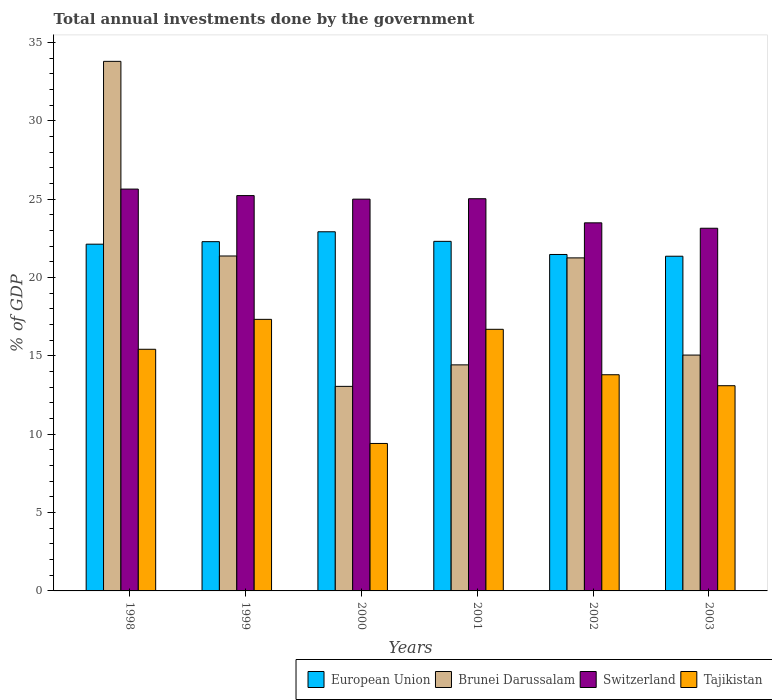How many different coloured bars are there?
Keep it short and to the point. 4. How many groups of bars are there?
Ensure brevity in your answer.  6. Are the number of bars per tick equal to the number of legend labels?
Provide a short and direct response. Yes. Are the number of bars on each tick of the X-axis equal?
Offer a very short reply. Yes. How many bars are there on the 1st tick from the left?
Give a very brief answer. 4. In how many cases, is the number of bars for a given year not equal to the number of legend labels?
Your answer should be compact. 0. What is the total annual investments done by the government in Switzerland in 2000?
Offer a very short reply. 25.01. Across all years, what is the maximum total annual investments done by the government in European Union?
Your response must be concise. 22.93. Across all years, what is the minimum total annual investments done by the government in European Union?
Keep it short and to the point. 21.37. In which year was the total annual investments done by the government in Brunei Darussalam minimum?
Your response must be concise. 2000. What is the total total annual investments done by the government in Brunei Darussalam in the graph?
Offer a very short reply. 118.99. What is the difference between the total annual investments done by the government in Switzerland in 2000 and that in 2003?
Make the answer very short. 1.86. What is the difference between the total annual investments done by the government in Switzerland in 1998 and the total annual investments done by the government in Brunei Darussalam in 1999?
Your response must be concise. 4.27. What is the average total annual investments done by the government in Tajikistan per year?
Offer a very short reply. 14.3. In the year 1999, what is the difference between the total annual investments done by the government in European Union and total annual investments done by the government in Brunei Darussalam?
Provide a short and direct response. 0.92. In how many years, is the total annual investments done by the government in Switzerland greater than 32 %?
Keep it short and to the point. 0. What is the ratio of the total annual investments done by the government in Brunei Darussalam in 1999 to that in 2000?
Your answer should be very brief. 1.64. Is the total annual investments done by the government in Brunei Darussalam in 2002 less than that in 2003?
Provide a succinct answer. No. Is the difference between the total annual investments done by the government in European Union in 1998 and 2003 greater than the difference between the total annual investments done by the government in Brunei Darussalam in 1998 and 2003?
Your response must be concise. No. What is the difference between the highest and the second highest total annual investments done by the government in Brunei Darussalam?
Give a very brief answer. 12.43. What is the difference between the highest and the lowest total annual investments done by the government in Tajikistan?
Provide a succinct answer. 7.92. Is the sum of the total annual investments done by the government in Brunei Darussalam in 1998 and 2000 greater than the maximum total annual investments done by the government in Tajikistan across all years?
Your answer should be compact. Yes. Is it the case that in every year, the sum of the total annual investments done by the government in Switzerland and total annual investments done by the government in Brunei Darussalam is greater than the sum of total annual investments done by the government in Tajikistan and total annual investments done by the government in European Union?
Offer a terse response. No. What does the 1st bar from the left in 1998 represents?
Give a very brief answer. European Union. What does the 3rd bar from the right in 2003 represents?
Your response must be concise. Brunei Darussalam. Is it the case that in every year, the sum of the total annual investments done by the government in Switzerland and total annual investments done by the government in Brunei Darussalam is greater than the total annual investments done by the government in Tajikistan?
Offer a very short reply. Yes. How many bars are there?
Your answer should be very brief. 24. Are all the bars in the graph horizontal?
Your answer should be compact. No. Are the values on the major ticks of Y-axis written in scientific E-notation?
Make the answer very short. No. Does the graph contain any zero values?
Keep it short and to the point. No. Where does the legend appear in the graph?
Offer a very short reply. Bottom right. How many legend labels are there?
Offer a very short reply. 4. What is the title of the graph?
Provide a short and direct response. Total annual investments done by the government. Does "Cameroon" appear as one of the legend labels in the graph?
Provide a succinct answer. No. What is the label or title of the Y-axis?
Ensure brevity in your answer.  % of GDP. What is the % of GDP in European Union in 1998?
Your answer should be very brief. 22.13. What is the % of GDP of Brunei Darussalam in 1998?
Your response must be concise. 33.81. What is the % of GDP in Switzerland in 1998?
Provide a succinct answer. 25.65. What is the % of GDP of Tajikistan in 1998?
Your answer should be compact. 15.43. What is the % of GDP in European Union in 1999?
Make the answer very short. 22.3. What is the % of GDP in Brunei Darussalam in 1999?
Provide a succinct answer. 21.38. What is the % of GDP of Switzerland in 1999?
Keep it short and to the point. 25.24. What is the % of GDP in Tajikistan in 1999?
Make the answer very short. 17.34. What is the % of GDP of European Union in 2000?
Keep it short and to the point. 22.93. What is the % of GDP of Brunei Darussalam in 2000?
Ensure brevity in your answer.  13.06. What is the % of GDP of Switzerland in 2000?
Your answer should be very brief. 25.01. What is the % of GDP in Tajikistan in 2000?
Ensure brevity in your answer.  9.41. What is the % of GDP in European Union in 2001?
Give a very brief answer. 22.31. What is the % of GDP of Brunei Darussalam in 2001?
Ensure brevity in your answer.  14.43. What is the % of GDP in Switzerland in 2001?
Keep it short and to the point. 25.04. What is the % of GDP in Tajikistan in 2001?
Offer a terse response. 16.7. What is the % of GDP of European Union in 2002?
Offer a terse response. 21.48. What is the % of GDP of Brunei Darussalam in 2002?
Offer a terse response. 21.26. What is the % of GDP of Switzerland in 2002?
Your answer should be very brief. 23.5. What is the % of GDP of Tajikistan in 2002?
Provide a succinct answer. 13.8. What is the % of GDP in European Union in 2003?
Your answer should be very brief. 21.37. What is the % of GDP in Brunei Darussalam in 2003?
Offer a very short reply. 15.06. What is the % of GDP in Switzerland in 2003?
Keep it short and to the point. 23.15. What is the % of GDP of Tajikistan in 2003?
Offer a very short reply. 13.1. Across all years, what is the maximum % of GDP of European Union?
Offer a very short reply. 22.93. Across all years, what is the maximum % of GDP of Brunei Darussalam?
Offer a very short reply. 33.81. Across all years, what is the maximum % of GDP of Switzerland?
Provide a succinct answer. 25.65. Across all years, what is the maximum % of GDP in Tajikistan?
Keep it short and to the point. 17.34. Across all years, what is the minimum % of GDP in European Union?
Your answer should be very brief. 21.37. Across all years, what is the minimum % of GDP of Brunei Darussalam?
Your answer should be very brief. 13.06. Across all years, what is the minimum % of GDP in Switzerland?
Your response must be concise. 23.15. Across all years, what is the minimum % of GDP in Tajikistan?
Your response must be concise. 9.41. What is the total % of GDP of European Union in the graph?
Ensure brevity in your answer.  132.51. What is the total % of GDP of Brunei Darussalam in the graph?
Provide a short and direct response. 118.99. What is the total % of GDP in Switzerland in the graph?
Keep it short and to the point. 147.58. What is the total % of GDP of Tajikistan in the graph?
Your answer should be compact. 85.77. What is the difference between the % of GDP of European Union in 1998 and that in 1999?
Ensure brevity in your answer.  -0.16. What is the difference between the % of GDP in Brunei Darussalam in 1998 and that in 1999?
Offer a very short reply. 12.43. What is the difference between the % of GDP of Switzerland in 1998 and that in 1999?
Your answer should be compact. 0.42. What is the difference between the % of GDP of Tajikistan in 1998 and that in 1999?
Offer a terse response. -1.91. What is the difference between the % of GDP in European Union in 1998 and that in 2000?
Provide a succinct answer. -0.79. What is the difference between the % of GDP in Brunei Darussalam in 1998 and that in 2000?
Provide a short and direct response. 20.75. What is the difference between the % of GDP in Switzerland in 1998 and that in 2000?
Provide a short and direct response. 0.64. What is the difference between the % of GDP of Tajikistan in 1998 and that in 2000?
Your answer should be compact. 6.01. What is the difference between the % of GDP in European Union in 1998 and that in 2001?
Your answer should be very brief. -0.18. What is the difference between the % of GDP of Brunei Darussalam in 1998 and that in 2001?
Your response must be concise. 19.38. What is the difference between the % of GDP of Switzerland in 1998 and that in 2001?
Your answer should be compact. 0.62. What is the difference between the % of GDP in Tajikistan in 1998 and that in 2001?
Your answer should be compact. -1.27. What is the difference between the % of GDP of European Union in 1998 and that in 2002?
Keep it short and to the point. 0.66. What is the difference between the % of GDP in Brunei Darussalam in 1998 and that in 2002?
Your answer should be very brief. 12.55. What is the difference between the % of GDP in Switzerland in 1998 and that in 2002?
Offer a very short reply. 2.15. What is the difference between the % of GDP in Tajikistan in 1998 and that in 2002?
Offer a very short reply. 1.63. What is the difference between the % of GDP of European Union in 1998 and that in 2003?
Keep it short and to the point. 0.77. What is the difference between the % of GDP of Brunei Darussalam in 1998 and that in 2003?
Provide a short and direct response. 18.75. What is the difference between the % of GDP of Switzerland in 1998 and that in 2003?
Provide a short and direct response. 2.5. What is the difference between the % of GDP of Tajikistan in 1998 and that in 2003?
Offer a terse response. 2.33. What is the difference between the % of GDP of European Union in 1999 and that in 2000?
Give a very brief answer. -0.63. What is the difference between the % of GDP in Brunei Darussalam in 1999 and that in 2000?
Ensure brevity in your answer.  8.32. What is the difference between the % of GDP of Switzerland in 1999 and that in 2000?
Provide a succinct answer. 0.23. What is the difference between the % of GDP of Tajikistan in 1999 and that in 2000?
Provide a short and direct response. 7.92. What is the difference between the % of GDP of European Union in 1999 and that in 2001?
Offer a terse response. -0.02. What is the difference between the % of GDP in Brunei Darussalam in 1999 and that in 2001?
Offer a terse response. 6.95. What is the difference between the % of GDP of Switzerland in 1999 and that in 2001?
Keep it short and to the point. 0.2. What is the difference between the % of GDP in Tajikistan in 1999 and that in 2001?
Provide a succinct answer. 0.64. What is the difference between the % of GDP of European Union in 1999 and that in 2002?
Ensure brevity in your answer.  0.82. What is the difference between the % of GDP of Brunei Darussalam in 1999 and that in 2002?
Your answer should be very brief. 0.12. What is the difference between the % of GDP of Switzerland in 1999 and that in 2002?
Provide a succinct answer. 1.74. What is the difference between the % of GDP of Tajikistan in 1999 and that in 2002?
Your answer should be compact. 3.54. What is the difference between the % of GDP of European Union in 1999 and that in 2003?
Offer a terse response. 0.93. What is the difference between the % of GDP of Brunei Darussalam in 1999 and that in 2003?
Your response must be concise. 6.32. What is the difference between the % of GDP of Switzerland in 1999 and that in 2003?
Provide a short and direct response. 2.08. What is the difference between the % of GDP in Tajikistan in 1999 and that in 2003?
Offer a very short reply. 4.24. What is the difference between the % of GDP in European Union in 2000 and that in 2001?
Offer a terse response. 0.61. What is the difference between the % of GDP of Brunei Darussalam in 2000 and that in 2001?
Offer a terse response. -1.37. What is the difference between the % of GDP in Switzerland in 2000 and that in 2001?
Offer a terse response. -0.03. What is the difference between the % of GDP in Tajikistan in 2000 and that in 2001?
Make the answer very short. -7.29. What is the difference between the % of GDP of European Union in 2000 and that in 2002?
Your answer should be very brief. 1.45. What is the difference between the % of GDP in Brunei Darussalam in 2000 and that in 2002?
Provide a succinct answer. -8.2. What is the difference between the % of GDP in Switzerland in 2000 and that in 2002?
Offer a very short reply. 1.51. What is the difference between the % of GDP of Tajikistan in 2000 and that in 2002?
Provide a short and direct response. -4.39. What is the difference between the % of GDP in European Union in 2000 and that in 2003?
Make the answer very short. 1.56. What is the difference between the % of GDP in Brunei Darussalam in 2000 and that in 2003?
Offer a terse response. -2. What is the difference between the % of GDP in Switzerland in 2000 and that in 2003?
Your answer should be compact. 1.86. What is the difference between the % of GDP of Tajikistan in 2000 and that in 2003?
Offer a terse response. -3.69. What is the difference between the % of GDP of European Union in 2001 and that in 2002?
Provide a short and direct response. 0.84. What is the difference between the % of GDP of Brunei Darussalam in 2001 and that in 2002?
Give a very brief answer. -6.83. What is the difference between the % of GDP of Switzerland in 2001 and that in 2002?
Offer a very short reply. 1.54. What is the difference between the % of GDP of European Union in 2001 and that in 2003?
Give a very brief answer. 0.95. What is the difference between the % of GDP in Brunei Darussalam in 2001 and that in 2003?
Provide a succinct answer. -0.63. What is the difference between the % of GDP in Switzerland in 2001 and that in 2003?
Offer a terse response. 1.88. What is the difference between the % of GDP in European Union in 2002 and that in 2003?
Keep it short and to the point. 0.11. What is the difference between the % of GDP of Brunei Darussalam in 2002 and that in 2003?
Give a very brief answer. 6.2. What is the difference between the % of GDP in Switzerland in 2002 and that in 2003?
Make the answer very short. 0.34. What is the difference between the % of GDP in Tajikistan in 2002 and that in 2003?
Make the answer very short. 0.7. What is the difference between the % of GDP of European Union in 1998 and the % of GDP of Brunei Darussalam in 1999?
Provide a short and direct response. 0.75. What is the difference between the % of GDP in European Union in 1998 and the % of GDP in Switzerland in 1999?
Your answer should be compact. -3.1. What is the difference between the % of GDP of European Union in 1998 and the % of GDP of Tajikistan in 1999?
Your answer should be very brief. 4.8. What is the difference between the % of GDP of Brunei Darussalam in 1998 and the % of GDP of Switzerland in 1999?
Your answer should be very brief. 8.57. What is the difference between the % of GDP of Brunei Darussalam in 1998 and the % of GDP of Tajikistan in 1999?
Keep it short and to the point. 16.47. What is the difference between the % of GDP of Switzerland in 1998 and the % of GDP of Tajikistan in 1999?
Ensure brevity in your answer.  8.32. What is the difference between the % of GDP of European Union in 1998 and the % of GDP of Brunei Darussalam in 2000?
Keep it short and to the point. 9.08. What is the difference between the % of GDP of European Union in 1998 and the % of GDP of Switzerland in 2000?
Provide a succinct answer. -2.87. What is the difference between the % of GDP in European Union in 1998 and the % of GDP in Tajikistan in 2000?
Keep it short and to the point. 12.72. What is the difference between the % of GDP in Brunei Darussalam in 1998 and the % of GDP in Switzerland in 2000?
Your answer should be compact. 8.8. What is the difference between the % of GDP in Brunei Darussalam in 1998 and the % of GDP in Tajikistan in 2000?
Offer a terse response. 24.39. What is the difference between the % of GDP in Switzerland in 1998 and the % of GDP in Tajikistan in 2000?
Make the answer very short. 16.24. What is the difference between the % of GDP of European Union in 1998 and the % of GDP of Brunei Darussalam in 2001?
Your answer should be compact. 7.7. What is the difference between the % of GDP of European Union in 1998 and the % of GDP of Switzerland in 2001?
Provide a succinct answer. -2.9. What is the difference between the % of GDP of European Union in 1998 and the % of GDP of Tajikistan in 2001?
Your answer should be very brief. 5.43. What is the difference between the % of GDP in Brunei Darussalam in 1998 and the % of GDP in Switzerland in 2001?
Provide a succinct answer. 8.77. What is the difference between the % of GDP in Brunei Darussalam in 1998 and the % of GDP in Tajikistan in 2001?
Make the answer very short. 17.11. What is the difference between the % of GDP of Switzerland in 1998 and the % of GDP of Tajikistan in 2001?
Your answer should be very brief. 8.95. What is the difference between the % of GDP in European Union in 1998 and the % of GDP in Brunei Darussalam in 2002?
Make the answer very short. 0.87. What is the difference between the % of GDP of European Union in 1998 and the % of GDP of Switzerland in 2002?
Offer a very short reply. -1.36. What is the difference between the % of GDP of European Union in 1998 and the % of GDP of Tajikistan in 2002?
Your answer should be compact. 8.33. What is the difference between the % of GDP of Brunei Darussalam in 1998 and the % of GDP of Switzerland in 2002?
Offer a terse response. 10.31. What is the difference between the % of GDP in Brunei Darussalam in 1998 and the % of GDP in Tajikistan in 2002?
Provide a short and direct response. 20.01. What is the difference between the % of GDP of Switzerland in 1998 and the % of GDP of Tajikistan in 2002?
Offer a terse response. 11.85. What is the difference between the % of GDP of European Union in 1998 and the % of GDP of Brunei Darussalam in 2003?
Ensure brevity in your answer.  7.08. What is the difference between the % of GDP in European Union in 1998 and the % of GDP in Switzerland in 2003?
Give a very brief answer. -1.02. What is the difference between the % of GDP of European Union in 1998 and the % of GDP of Tajikistan in 2003?
Make the answer very short. 9.03. What is the difference between the % of GDP in Brunei Darussalam in 1998 and the % of GDP in Switzerland in 2003?
Your response must be concise. 10.65. What is the difference between the % of GDP in Brunei Darussalam in 1998 and the % of GDP in Tajikistan in 2003?
Make the answer very short. 20.71. What is the difference between the % of GDP of Switzerland in 1998 and the % of GDP of Tajikistan in 2003?
Ensure brevity in your answer.  12.55. What is the difference between the % of GDP in European Union in 1999 and the % of GDP in Brunei Darussalam in 2000?
Make the answer very short. 9.24. What is the difference between the % of GDP in European Union in 1999 and the % of GDP in Switzerland in 2000?
Offer a very short reply. -2.71. What is the difference between the % of GDP in European Union in 1999 and the % of GDP in Tajikistan in 2000?
Your answer should be very brief. 12.88. What is the difference between the % of GDP of Brunei Darussalam in 1999 and the % of GDP of Switzerland in 2000?
Provide a short and direct response. -3.63. What is the difference between the % of GDP of Brunei Darussalam in 1999 and the % of GDP of Tajikistan in 2000?
Your answer should be compact. 11.97. What is the difference between the % of GDP of Switzerland in 1999 and the % of GDP of Tajikistan in 2000?
Ensure brevity in your answer.  15.82. What is the difference between the % of GDP of European Union in 1999 and the % of GDP of Brunei Darussalam in 2001?
Your answer should be very brief. 7.87. What is the difference between the % of GDP of European Union in 1999 and the % of GDP of Switzerland in 2001?
Offer a very short reply. -2.74. What is the difference between the % of GDP of European Union in 1999 and the % of GDP of Tajikistan in 2001?
Your answer should be very brief. 5.6. What is the difference between the % of GDP in Brunei Darussalam in 1999 and the % of GDP in Switzerland in 2001?
Your answer should be very brief. -3.66. What is the difference between the % of GDP in Brunei Darussalam in 1999 and the % of GDP in Tajikistan in 2001?
Ensure brevity in your answer.  4.68. What is the difference between the % of GDP in Switzerland in 1999 and the % of GDP in Tajikistan in 2001?
Ensure brevity in your answer.  8.54. What is the difference between the % of GDP in European Union in 1999 and the % of GDP in Brunei Darussalam in 2002?
Ensure brevity in your answer.  1.04. What is the difference between the % of GDP in European Union in 1999 and the % of GDP in Switzerland in 2002?
Offer a terse response. -1.2. What is the difference between the % of GDP of European Union in 1999 and the % of GDP of Tajikistan in 2002?
Offer a very short reply. 8.5. What is the difference between the % of GDP of Brunei Darussalam in 1999 and the % of GDP of Switzerland in 2002?
Your answer should be very brief. -2.12. What is the difference between the % of GDP of Brunei Darussalam in 1999 and the % of GDP of Tajikistan in 2002?
Offer a terse response. 7.58. What is the difference between the % of GDP in Switzerland in 1999 and the % of GDP in Tajikistan in 2002?
Your answer should be very brief. 11.44. What is the difference between the % of GDP of European Union in 1999 and the % of GDP of Brunei Darussalam in 2003?
Ensure brevity in your answer.  7.24. What is the difference between the % of GDP in European Union in 1999 and the % of GDP in Switzerland in 2003?
Provide a succinct answer. -0.86. What is the difference between the % of GDP in European Union in 1999 and the % of GDP in Tajikistan in 2003?
Offer a terse response. 9.2. What is the difference between the % of GDP in Brunei Darussalam in 1999 and the % of GDP in Switzerland in 2003?
Provide a short and direct response. -1.77. What is the difference between the % of GDP of Brunei Darussalam in 1999 and the % of GDP of Tajikistan in 2003?
Your response must be concise. 8.28. What is the difference between the % of GDP in Switzerland in 1999 and the % of GDP in Tajikistan in 2003?
Make the answer very short. 12.14. What is the difference between the % of GDP of European Union in 2000 and the % of GDP of Brunei Darussalam in 2001?
Your answer should be compact. 8.5. What is the difference between the % of GDP in European Union in 2000 and the % of GDP in Switzerland in 2001?
Offer a very short reply. -2.11. What is the difference between the % of GDP of European Union in 2000 and the % of GDP of Tajikistan in 2001?
Provide a short and direct response. 6.23. What is the difference between the % of GDP of Brunei Darussalam in 2000 and the % of GDP of Switzerland in 2001?
Offer a very short reply. -11.98. What is the difference between the % of GDP of Brunei Darussalam in 2000 and the % of GDP of Tajikistan in 2001?
Offer a terse response. -3.64. What is the difference between the % of GDP of Switzerland in 2000 and the % of GDP of Tajikistan in 2001?
Make the answer very short. 8.31. What is the difference between the % of GDP in European Union in 2000 and the % of GDP in Brunei Darussalam in 2002?
Provide a succinct answer. 1.67. What is the difference between the % of GDP in European Union in 2000 and the % of GDP in Switzerland in 2002?
Provide a short and direct response. -0.57. What is the difference between the % of GDP in European Union in 2000 and the % of GDP in Tajikistan in 2002?
Provide a succinct answer. 9.13. What is the difference between the % of GDP in Brunei Darussalam in 2000 and the % of GDP in Switzerland in 2002?
Make the answer very short. -10.44. What is the difference between the % of GDP in Brunei Darussalam in 2000 and the % of GDP in Tajikistan in 2002?
Your answer should be compact. -0.74. What is the difference between the % of GDP of Switzerland in 2000 and the % of GDP of Tajikistan in 2002?
Your response must be concise. 11.21. What is the difference between the % of GDP of European Union in 2000 and the % of GDP of Brunei Darussalam in 2003?
Keep it short and to the point. 7.87. What is the difference between the % of GDP of European Union in 2000 and the % of GDP of Switzerland in 2003?
Ensure brevity in your answer.  -0.23. What is the difference between the % of GDP of European Union in 2000 and the % of GDP of Tajikistan in 2003?
Provide a succinct answer. 9.83. What is the difference between the % of GDP in Brunei Darussalam in 2000 and the % of GDP in Switzerland in 2003?
Provide a short and direct response. -10.09. What is the difference between the % of GDP in Brunei Darussalam in 2000 and the % of GDP in Tajikistan in 2003?
Your response must be concise. -0.04. What is the difference between the % of GDP of Switzerland in 2000 and the % of GDP of Tajikistan in 2003?
Make the answer very short. 11.91. What is the difference between the % of GDP of European Union in 2001 and the % of GDP of Brunei Darussalam in 2002?
Ensure brevity in your answer.  1.06. What is the difference between the % of GDP in European Union in 2001 and the % of GDP in Switzerland in 2002?
Offer a very short reply. -1.18. What is the difference between the % of GDP in European Union in 2001 and the % of GDP in Tajikistan in 2002?
Offer a very short reply. 8.51. What is the difference between the % of GDP of Brunei Darussalam in 2001 and the % of GDP of Switzerland in 2002?
Provide a short and direct response. -9.07. What is the difference between the % of GDP in Brunei Darussalam in 2001 and the % of GDP in Tajikistan in 2002?
Make the answer very short. 0.63. What is the difference between the % of GDP in Switzerland in 2001 and the % of GDP in Tajikistan in 2002?
Offer a very short reply. 11.24. What is the difference between the % of GDP in European Union in 2001 and the % of GDP in Brunei Darussalam in 2003?
Offer a terse response. 7.26. What is the difference between the % of GDP in European Union in 2001 and the % of GDP in Switzerland in 2003?
Offer a terse response. -0.84. What is the difference between the % of GDP of European Union in 2001 and the % of GDP of Tajikistan in 2003?
Give a very brief answer. 9.21. What is the difference between the % of GDP of Brunei Darussalam in 2001 and the % of GDP of Switzerland in 2003?
Make the answer very short. -8.72. What is the difference between the % of GDP of Brunei Darussalam in 2001 and the % of GDP of Tajikistan in 2003?
Your answer should be very brief. 1.33. What is the difference between the % of GDP in Switzerland in 2001 and the % of GDP in Tajikistan in 2003?
Offer a terse response. 11.94. What is the difference between the % of GDP of European Union in 2002 and the % of GDP of Brunei Darussalam in 2003?
Keep it short and to the point. 6.42. What is the difference between the % of GDP of European Union in 2002 and the % of GDP of Switzerland in 2003?
Provide a succinct answer. -1.67. What is the difference between the % of GDP in European Union in 2002 and the % of GDP in Tajikistan in 2003?
Make the answer very short. 8.38. What is the difference between the % of GDP in Brunei Darussalam in 2002 and the % of GDP in Switzerland in 2003?
Offer a terse response. -1.89. What is the difference between the % of GDP in Brunei Darussalam in 2002 and the % of GDP in Tajikistan in 2003?
Provide a succinct answer. 8.16. What is the difference between the % of GDP of Switzerland in 2002 and the % of GDP of Tajikistan in 2003?
Offer a very short reply. 10.4. What is the average % of GDP of European Union per year?
Provide a succinct answer. 22.09. What is the average % of GDP of Brunei Darussalam per year?
Your response must be concise. 19.83. What is the average % of GDP of Switzerland per year?
Your answer should be very brief. 24.6. What is the average % of GDP in Tajikistan per year?
Ensure brevity in your answer.  14.3. In the year 1998, what is the difference between the % of GDP of European Union and % of GDP of Brunei Darussalam?
Provide a succinct answer. -11.67. In the year 1998, what is the difference between the % of GDP of European Union and % of GDP of Switzerland?
Give a very brief answer. -3.52. In the year 1998, what is the difference between the % of GDP of European Union and % of GDP of Tajikistan?
Your answer should be very brief. 6.71. In the year 1998, what is the difference between the % of GDP in Brunei Darussalam and % of GDP in Switzerland?
Ensure brevity in your answer.  8.15. In the year 1998, what is the difference between the % of GDP of Brunei Darussalam and % of GDP of Tajikistan?
Make the answer very short. 18.38. In the year 1998, what is the difference between the % of GDP of Switzerland and % of GDP of Tajikistan?
Your answer should be compact. 10.23. In the year 1999, what is the difference between the % of GDP of European Union and % of GDP of Brunei Darussalam?
Make the answer very short. 0.92. In the year 1999, what is the difference between the % of GDP of European Union and % of GDP of Switzerland?
Your answer should be very brief. -2.94. In the year 1999, what is the difference between the % of GDP in European Union and % of GDP in Tajikistan?
Your answer should be very brief. 4.96. In the year 1999, what is the difference between the % of GDP in Brunei Darussalam and % of GDP in Switzerland?
Give a very brief answer. -3.86. In the year 1999, what is the difference between the % of GDP in Brunei Darussalam and % of GDP in Tajikistan?
Ensure brevity in your answer.  4.04. In the year 1999, what is the difference between the % of GDP of Switzerland and % of GDP of Tajikistan?
Make the answer very short. 7.9. In the year 2000, what is the difference between the % of GDP in European Union and % of GDP in Brunei Darussalam?
Offer a very short reply. 9.87. In the year 2000, what is the difference between the % of GDP in European Union and % of GDP in Switzerland?
Offer a terse response. -2.08. In the year 2000, what is the difference between the % of GDP of European Union and % of GDP of Tajikistan?
Provide a short and direct response. 13.51. In the year 2000, what is the difference between the % of GDP in Brunei Darussalam and % of GDP in Switzerland?
Make the answer very short. -11.95. In the year 2000, what is the difference between the % of GDP of Brunei Darussalam and % of GDP of Tajikistan?
Your answer should be very brief. 3.64. In the year 2000, what is the difference between the % of GDP in Switzerland and % of GDP in Tajikistan?
Provide a short and direct response. 15.6. In the year 2001, what is the difference between the % of GDP in European Union and % of GDP in Brunei Darussalam?
Your answer should be compact. 7.88. In the year 2001, what is the difference between the % of GDP in European Union and % of GDP in Switzerland?
Provide a succinct answer. -2.72. In the year 2001, what is the difference between the % of GDP in European Union and % of GDP in Tajikistan?
Keep it short and to the point. 5.61. In the year 2001, what is the difference between the % of GDP in Brunei Darussalam and % of GDP in Switzerland?
Offer a very short reply. -10.61. In the year 2001, what is the difference between the % of GDP in Brunei Darussalam and % of GDP in Tajikistan?
Keep it short and to the point. -2.27. In the year 2001, what is the difference between the % of GDP of Switzerland and % of GDP of Tajikistan?
Your response must be concise. 8.34. In the year 2002, what is the difference between the % of GDP in European Union and % of GDP in Brunei Darussalam?
Your answer should be very brief. 0.22. In the year 2002, what is the difference between the % of GDP in European Union and % of GDP in Switzerland?
Your answer should be compact. -2.02. In the year 2002, what is the difference between the % of GDP of European Union and % of GDP of Tajikistan?
Your answer should be compact. 7.68. In the year 2002, what is the difference between the % of GDP in Brunei Darussalam and % of GDP in Switzerland?
Make the answer very short. -2.24. In the year 2002, what is the difference between the % of GDP in Brunei Darussalam and % of GDP in Tajikistan?
Offer a terse response. 7.46. In the year 2002, what is the difference between the % of GDP in Switzerland and % of GDP in Tajikistan?
Give a very brief answer. 9.7. In the year 2003, what is the difference between the % of GDP in European Union and % of GDP in Brunei Darussalam?
Keep it short and to the point. 6.31. In the year 2003, what is the difference between the % of GDP of European Union and % of GDP of Switzerland?
Ensure brevity in your answer.  -1.79. In the year 2003, what is the difference between the % of GDP in European Union and % of GDP in Tajikistan?
Your answer should be compact. 8.27. In the year 2003, what is the difference between the % of GDP in Brunei Darussalam and % of GDP in Switzerland?
Your response must be concise. -8.1. In the year 2003, what is the difference between the % of GDP of Brunei Darussalam and % of GDP of Tajikistan?
Your answer should be compact. 1.96. In the year 2003, what is the difference between the % of GDP in Switzerland and % of GDP in Tajikistan?
Provide a short and direct response. 10.05. What is the ratio of the % of GDP of European Union in 1998 to that in 1999?
Offer a terse response. 0.99. What is the ratio of the % of GDP of Brunei Darussalam in 1998 to that in 1999?
Offer a very short reply. 1.58. What is the ratio of the % of GDP in Switzerland in 1998 to that in 1999?
Your response must be concise. 1.02. What is the ratio of the % of GDP of Tajikistan in 1998 to that in 1999?
Make the answer very short. 0.89. What is the ratio of the % of GDP of European Union in 1998 to that in 2000?
Provide a short and direct response. 0.97. What is the ratio of the % of GDP of Brunei Darussalam in 1998 to that in 2000?
Your response must be concise. 2.59. What is the ratio of the % of GDP of Switzerland in 1998 to that in 2000?
Your response must be concise. 1.03. What is the ratio of the % of GDP of Tajikistan in 1998 to that in 2000?
Offer a very short reply. 1.64. What is the ratio of the % of GDP in European Union in 1998 to that in 2001?
Provide a short and direct response. 0.99. What is the ratio of the % of GDP in Brunei Darussalam in 1998 to that in 2001?
Your answer should be very brief. 2.34. What is the ratio of the % of GDP in Switzerland in 1998 to that in 2001?
Your answer should be compact. 1.02. What is the ratio of the % of GDP in Tajikistan in 1998 to that in 2001?
Offer a terse response. 0.92. What is the ratio of the % of GDP in European Union in 1998 to that in 2002?
Make the answer very short. 1.03. What is the ratio of the % of GDP of Brunei Darussalam in 1998 to that in 2002?
Keep it short and to the point. 1.59. What is the ratio of the % of GDP in Switzerland in 1998 to that in 2002?
Your answer should be compact. 1.09. What is the ratio of the % of GDP of Tajikistan in 1998 to that in 2002?
Ensure brevity in your answer.  1.12. What is the ratio of the % of GDP of European Union in 1998 to that in 2003?
Provide a succinct answer. 1.04. What is the ratio of the % of GDP in Brunei Darussalam in 1998 to that in 2003?
Offer a very short reply. 2.25. What is the ratio of the % of GDP in Switzerland in 1998 to that in 2003?
Your answer should be compact. 1.11. What is the ratio of the % of GDP in Tajikistan in 1998 to that in 2003?
Offer a very short reply. 1.18. What is the ratio of the % of GDP in European Union in 1999 to that in 2000?
Provide a short and direct response. 0.97. What is the ratio of the % of GDP in Brunei Darussalam in 1999 to that in 2000?
Ensure brevity in your answer.  1.64. What is the ratio of the % of GDP of Switzerland in 1999 to that in 2000?
Your answer should be compact. 1.01. What is the ratio of the % of GDP of Tajikistan in 1999 to that in 2000?
Keep it short and to the point. 1.84. What is the ratio of the % of GDP in Brunei Darussalam in 1999 to that in 2001?
Ensure brevity in your answer.  1.48. What is the ratio of the % of GDP in Switzerland in 1999 to that in 2001?
Offer a very short reply. 1.01. What is the ratio of the % of GDP of Tajikistan in 1999 to that in 2001?
Keep it short and to the point. 1.04. What is the ratio of the % of GDP in European Union in 1999 to that in 2002?
Give a very brief answer. 1.04. What is the ratio of the % of GDP in Switzerland in 1999 to that in 2002?
Offer a very short reply. 1.07. What is the ratio of the % of GDP in Tajikistan in 1999 to that in 2002?
Provide a short and direct response. 1.26. What is the ratio of the % of GDP in European Union in 1999 to that in 2003?
Give a very brief answer. 1.04. What is the ratio of the % of GDP of Brunei Darussalam in 1999 to that in 2003?
Ensure brevity in your answer.  1.42. What is the ratio of the % of GDP of Switzerland in 1999 to that in 2003?
Make the answer very short. 1.09. What is the ratio of the % of GDP of Tajikistan in 1999 to that in 2003?
Give a very brief answer. 1.32. What is the ratio of the % of GDP in European Union in 2000 to that in 2001?
Provide a succinct answer. 1.03. What is the ratio of the % of GDP of Brunei Darussalam in 2000 to that in 2001?
Ensure brevity in your answer.  0.9. What is the ratio of the % of GDP of Switzerland in 2000 to that in 2001?
Your response must be concise. 1. What is the ratio of the % of GDP in Tajikistan in 2000 to that in 2001?
Offer a terse response. 0.56. What is the ratio of the % of GDP in European Union in 2000 to that in 2002?
Make the answer very short. 1.07. What is the ratio of the % of GDP of Brunei Darussalam in 2000 to that in 2002?
Your response must be concise. 0.61. What is the ratio of the % of GDP in Switzerland in 2000 to that in 2002?
Make the answer very short. 1.06. What is the ratio of the % of GDP in Tajikistan in 2000 to that in 2002?
Offer a terse response. 0.68. What is the ratio of the % of GDP of European Union in 2000 to that in 2003?
Give a very brief answer. 1.07. What is the ratio of the % of GDP in Brunei Darussalam in 2000 to that in 2003?
Offer a very short reply. 0.87. What is the ratio of the % of GDP in Switzerland in 2000 to that in 2003?
Your response must be concise. 1.08. What is the ratio of the % of GDP in Tajikistan in 2000 to that in 2003?
Your answer should be very brief. 0.72. What is the ratio of the % of GDP of European Union in 2001 to that in 2002?
Offer a terse response. 1.04. What is the ratio of the % of GDP in Brunei Darussalam in 2001 to that in 2002?
Ensure brevity in your answer.  0.68. What is the ratio of the % of GDP of Switzerland in 2001 to that in 2002?
Your answer should be compact. 1.07. What is the ratio of the % of GDP of Tajikistan in 2001 to that in 2002?
Keep it short and to the point. 1.21. What is the ratio of the % of GDP of European Union in 2001 to that in 2003?
Offer a very short reply. 1.04. What is the ratio of the % of GDP of Brunei Darussalam in 2001 to that in 2003?
Ensure brevity in your answer.  0.96. What is the ratio of the % of GDP in Switzerland in 2001 to that in 2003?
Your answer should be very brief. 1.08. What is the ratio of the % of GDP in Tajikistan in 2001 to that in 2003?
Give a very brief answer. 1.27. What is the ratio of the % of GDP of European Union in 2002 to that in 2003?
Your answer should be compact. 1.01. What is the ratio of the % of GDP of Brunei Darussalam in 2002 to that in 2003?
Your answer should be very brief. 1.41. What is the ratio of the % of GDP of Switzerland in 2002 to that in 2003?
Make the answer very short. 1.01. What is the ratio of the % of GDP of Tajikistan in 2002 to that in 2003?
Provide a succinct answer. 1.05. What is the difference between the highest and the second highest % of GDP of European Union?
Offer a terse response. 0.61. What is the difference between the highest and the second highest % of GDP in Brunei Darussalam?
Provide a succinct answer. 12.43. What is the difference between the highest and the second highest % of GDP in Switzerland?
Keep it short and to the point. 0.42. What is the difference between the highest and the second highest % of GDP in Tajikistan?
Offer a terse response. 0.64. What is the difference between the highest and the lowest % of GDP of European Union?
Ensure brevity in your answer.  1.56. What is the difference between the highest and the lowest % of GDP in Brunei Darussalam?
Give a very brief answer. 20.75. What is the difference between the highest and the lowest % of GDP of Switzerland?
Your answer should be compact. 2.5. What is the difference between the highest and the lowest % of GDP of Tajikistan?
Keep it short and to the point. 7.92. 